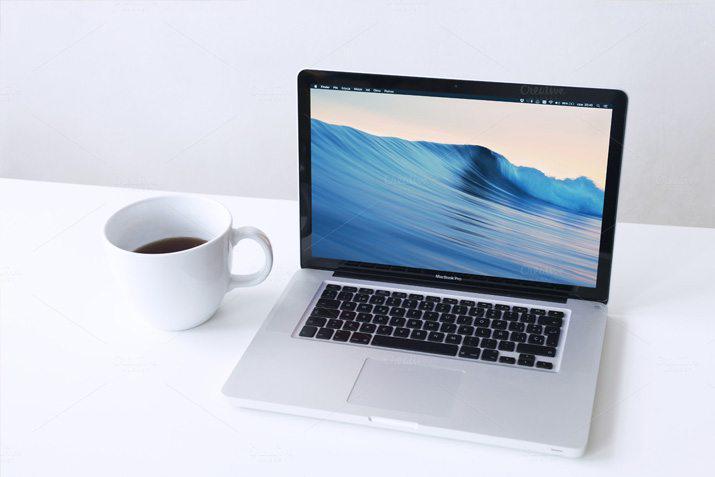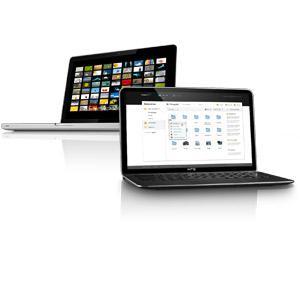The first image is the image on the left, the second image is the image on the right. For the images displayed, is the sentence "There are more devices in the image on the right." factually correct? Answer yes or no. Yes. The first image is the image on the left, the second image is the image on the right. Analyze the images presented: Is the assertion "The left image shows exactly one open forward-facing laptop on a white table, and the right image shows one open, forward-facing laptop overlapping another open, forward-facing laptop." valid? Answer yes or no. Yes. 